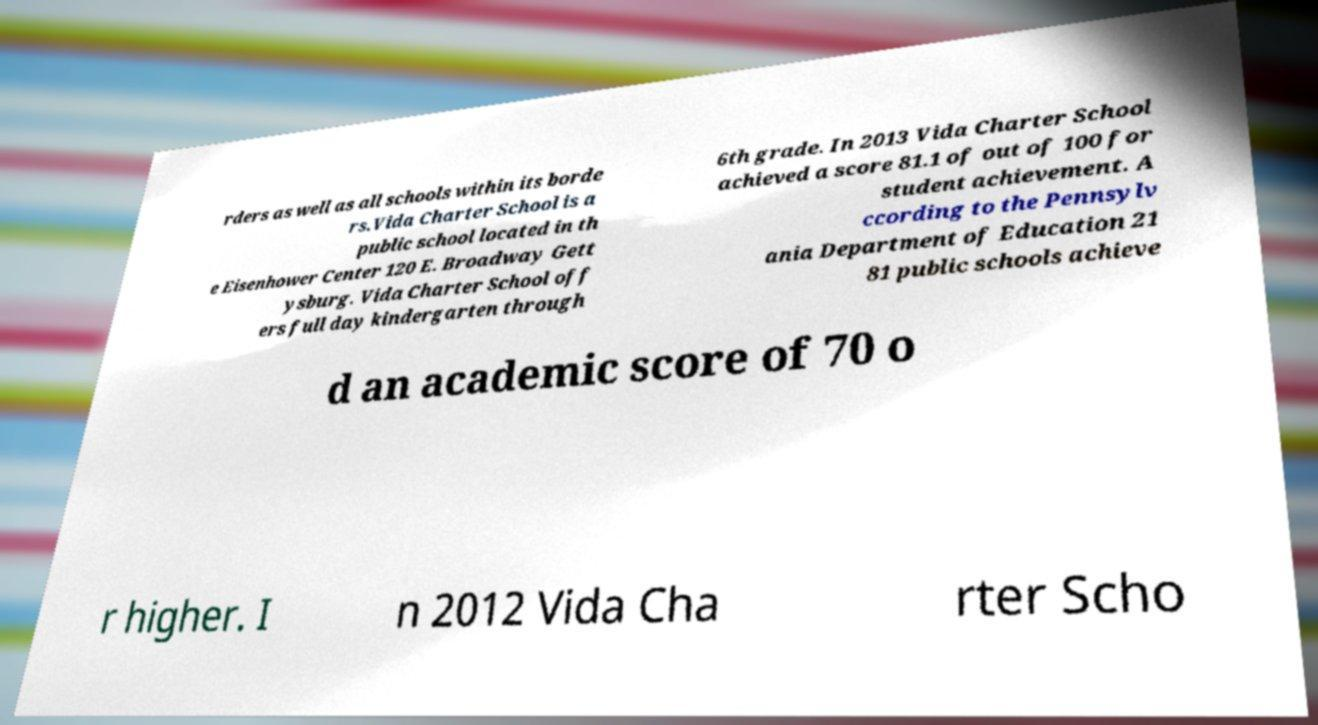Can you accurately transcribe the text from the provided image for me? rders as well as all schools within its borde rs.Vida Charter School is a public school located in th e Eisenhower Center 120 E. Broadway Gett ysburg. Vida Charter School off ers full day kindergarten through 6th grade. In 2013 Vida Charter School achieved a score 81.1 of out of 100 for student achievement. A ccording to the Pennsylv ania Department of Education 21 81 public schools achieve d an academic score of 70 o r higher. I n 2012 Vida Cha rter Scho 